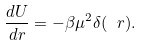<formula> <loc_0><loc_0><loc_500><loc_500>\frac { d U } { d r } = - \beta \mu ^ { 2 } \delta ( \ r ) .</formula> 